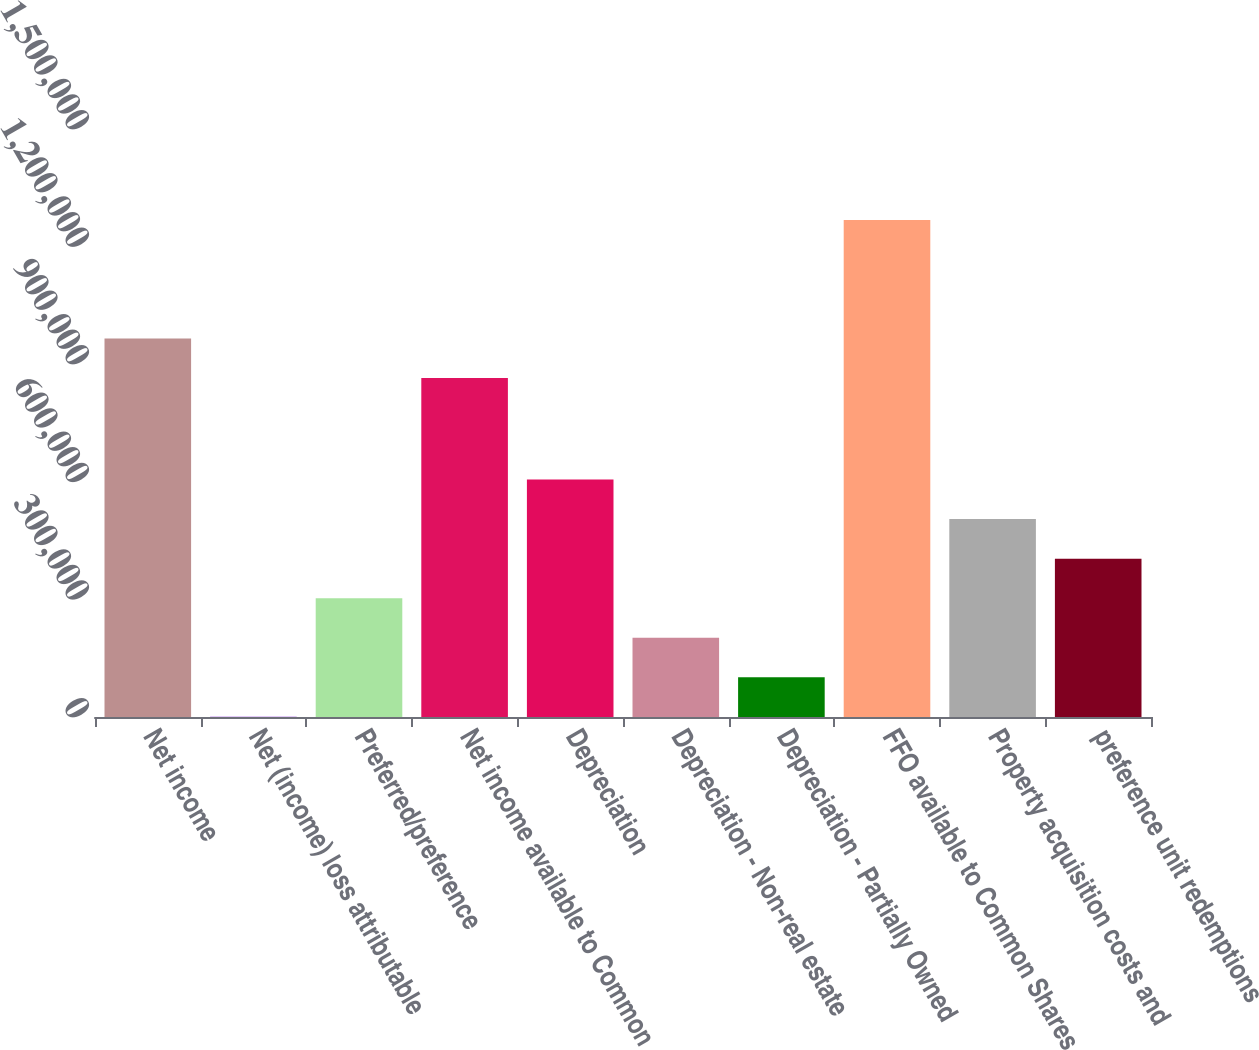Convert chart. <chart><loc_0><loc_0><loc_500><loc_500><bar_chart><fcel>Net income<fcel>Net (income) loss attributable<fcel>Preferred/preference<fcel>Net income available to Common<fcel>Depreciation<fcel>Depreciation - Non-real estate<fcel>Depreciation - Partially Owned<fcel>FFO available to Common Shares<fcel>Property acquisition costs and<fcel>preference unit redemptions<nl><fcel>965641<fcel>844<fcel>303208<fcel>864853<fcel>605572<fcel>202420<fcel>101632<fcel>1.268e+06<fcel>504784<fcel>403996<nl></chart> 